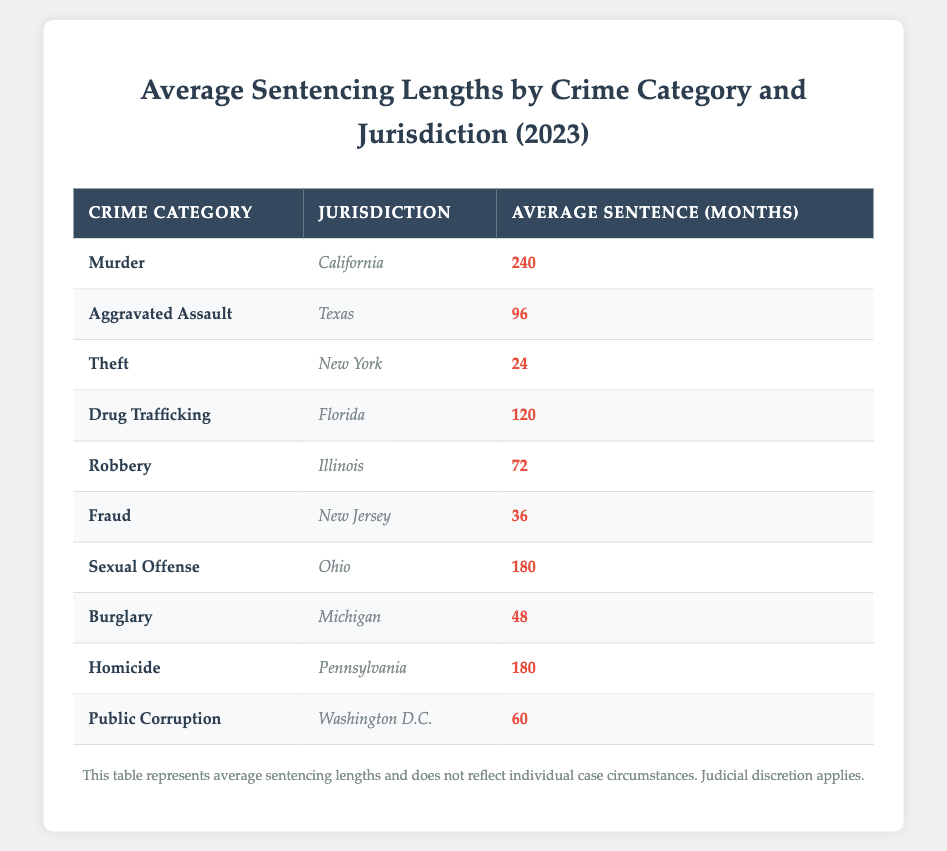What is the average sentencing length for Murder in California? The table specifies that the average sentencing length for Murder in California is listed under the respective columns. Referring to the row for Murder in California, the average length is 240 months.
Answer: 240 months Which crime category in Illinois has a shorter average sentencing length, Robbery or Theft? According to the table, the average sentencing length for Robbery in Illinois is 72 months, while Theft is not listed in Illinois but rather in New York with an average of 24 months. Therefore, Robbery is longer than Theft, since it's not relevant to Illinois.
Answer: Robbery has a longer sentencing length Is the average sentencing length for Drug Trafficking in Florida greater than that for Sexual Offense in Ohio? Looking at the table, the average length for Drug Trafficking in Florida is 120 months, whereas for Sexual Offense in Ohio, it's 180 months. Since 120 is less than 180, then Drug Trafficking has a shorter average sentencing length.
Answer: No What is the total average sentencing length for Homicide in Pennsylvania and Sexual Offense in Ohio combined? The average for Homicide in Pennsylvania is 180 months and for Sexual Offense in Ohio is also 180 months. Adding these values gives us 180 + 180 = 360 months for the combined total.
Answer: 360 months Which jurisdiction has the longest average sentence and what is that sentence for? The table reveals that California has the longest average sentence for Murder at 240 months. By examining all the jurisdictions and their corresponding lengths, it's clear California has the highest at 240 months.
Answer: California for Murder How many jurisdictions have an average sentencing length of less than 48 months? Looking at the table, the only jurisdiction with a sentencing length below 48 months is Theft in New York with 24 months, which totals 1 jurisdiction.
Answer: 1 jurisdiction What is the average of the average sentencing lengths for all the crimes listed? To find the average, we sum all the provided averages: 240 (Murder) + 96 (Aggravated Assault) + 24 (Theft) + 120 (Drug Trafficking) + 72 (Robbery) + 36 (Fraud) + 180 (Sexual Offense) + 48 (Burglary) + 180 (Homicide) + 60 (Public Corruption) = 1800 months across 10 categories. The average is 1800 / 10 = 180 months.
Answer: 180 months Is the average sentencing length for Fraud in New Jersey equal to that for Burglary in Michigan? According to the data, Fraud in New Jersey is 36 months and Burglary in Michigan is 48 months. Since these two numbers are not equal, the answer is no.
Answer: No Which crime category has the third highest average sentencing length and what is that length? Analyzing the lengths, the highest is Murder (240), next is Sexual Offense (180), and then Homicide (180). In this case, both Sexual Offense and Homicide tie for the third position. However, if we must choose one, we could consider Sexual Offense due to its prior position. Therefore, the third highest is also tied at 180 months.
Answer: Sexual Offense and Homicide both at 180 months 